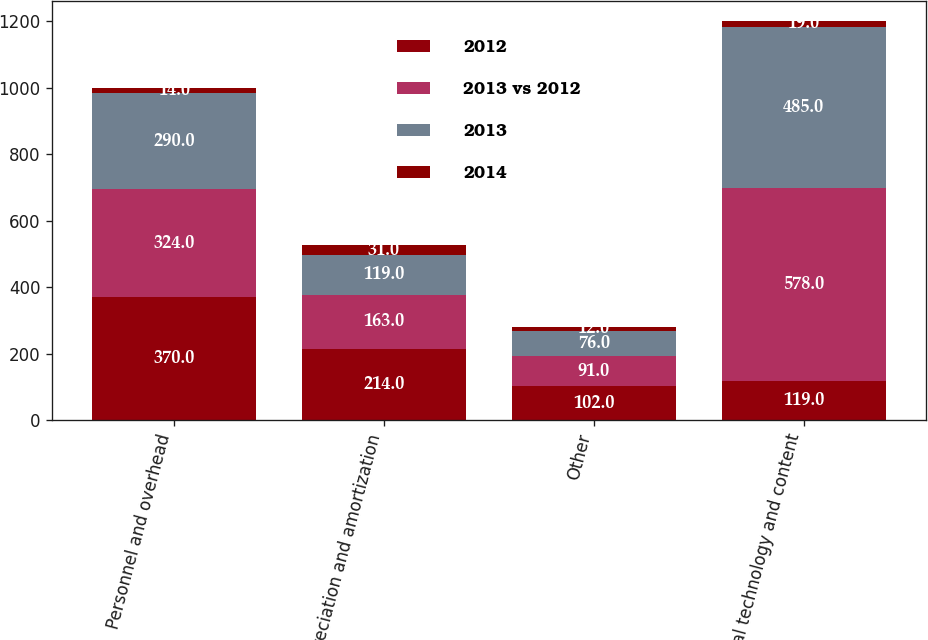<chart> <loc_0><loc_0><loc_500><loc_500><stacked_bar_chart><ecel><fcel>Personnel and overhead<fcel>Depreciation and amortization<fcel>Other<fcel>Total technology and content<nl><fcel>2012<fcel>370<fcel>214<fcel>102<fcel>119<nl><fcel>2013 vs 2012<fcel>324<fcel>163<fcel>91<fcel>578<nl><fcel>2013<fcel>290<fcel>119<fcel>76<fcel>485<nl><fcel>2014<fcel>14<fcel>31<fcel>12<fcel>19<nl></chart> 